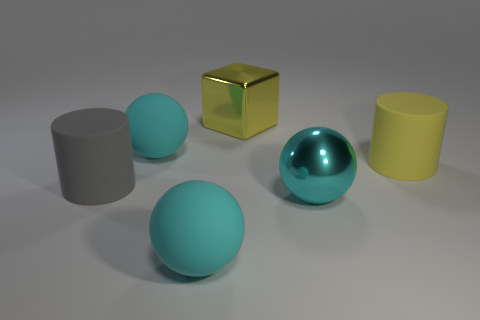Are there fewer big gray matte cylinders than balls?
Give a very brief answer. Yes. There is a thing that is both to the right of the big yellow cube and behind the big metal ball; what is its size?
Keep it short and to the point. Large. Do the gray object and the yellow block have the same size?
Provide a succinct answer. Yes. Do the rubber sphere that is behind the yellow cylinder and the big metallic cube have the same color?
Offer a very short reply. No. How many large rubber things are in front of the yellow rubber cylinder?
Offer a terse response. 2. Is the number of tiny yellow rubber spheres greater than the number of big gray cylinders?
Offer a terse response. No. What shape is the object that is both in front of the yellow shiny object and behind the large yellow matte cylinder?
Offer a very short reply. Sphere. Is there a big red metal cylinder?
Give a very brief answer. No. There is a large gray thing that is the same shape as the large yellow rubber thing; what is it made of?
Provide a short and direct response. Rubber. What is the shape of the large metal thing that is in front of the rubber cylinder that is right of the large cyan ball behind the cyan shiny ball?
Provide a succinct answer. Sphere. 